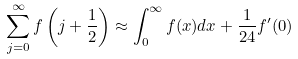Convert formula to latex. <formula><loc_0><loc_0><loc_500><loc_500>\sum _ { j = 0 } ^ { \infty } f \left ( j + \frac { 1 } { 2 } \right ) \approx \int _ { 0 } ^ { \infty } f ( x ) d x + \frac { 1 } { 2 4 } f ^ { \prime } ( 0 )</formula> 